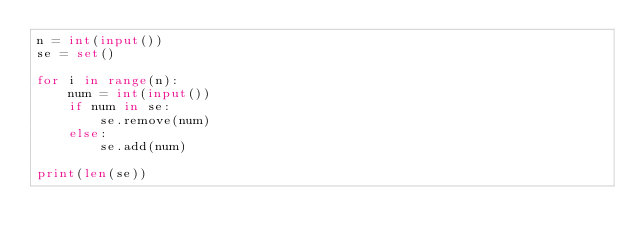Convert code to text. <code><loc_0><loc_0><loc_500><loc_500><_Python_>n = int(input())
se = set()

for i in range(n):
    num = int(input())
    if num in se:
        se.remove(num)
    else:
        se.add(num)

print(len(se))</code> 